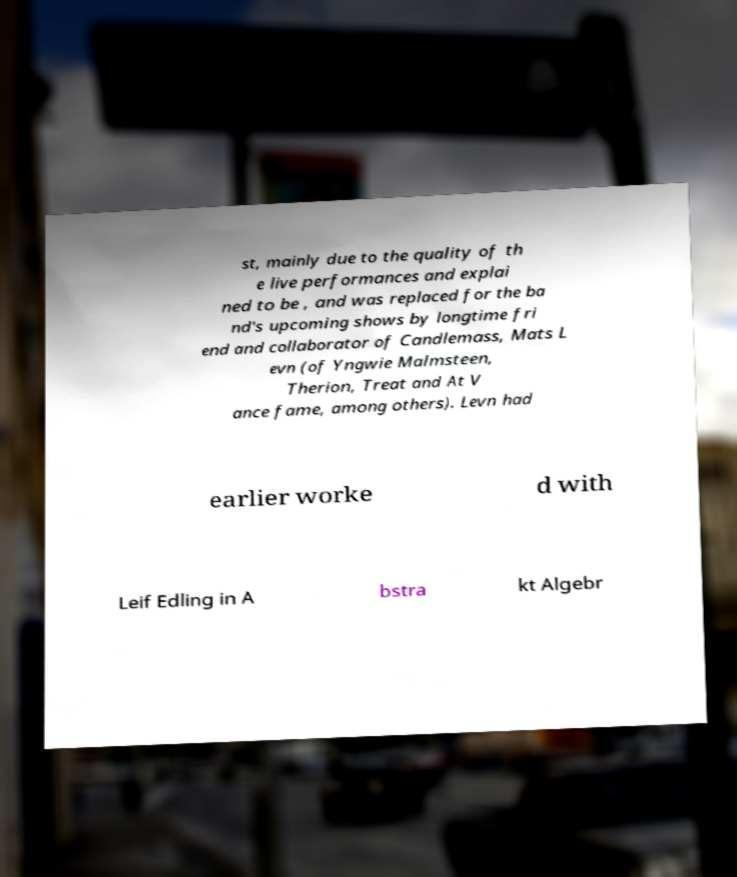For documentation purposes, I need the text within this image transcribed. Could you provide that? st, mainly due to the quality of th e live performances and explai ned to be , and was replaced for the ba nd's upcoming shows by longtime fri end and collaborator of Candlemass, Mats L evn (of Yngwie Malmsteen, Therion, Treat and At V ance fame, among others). Levn had earlier worke d with Leif Edling in A bstra kt Algebr 